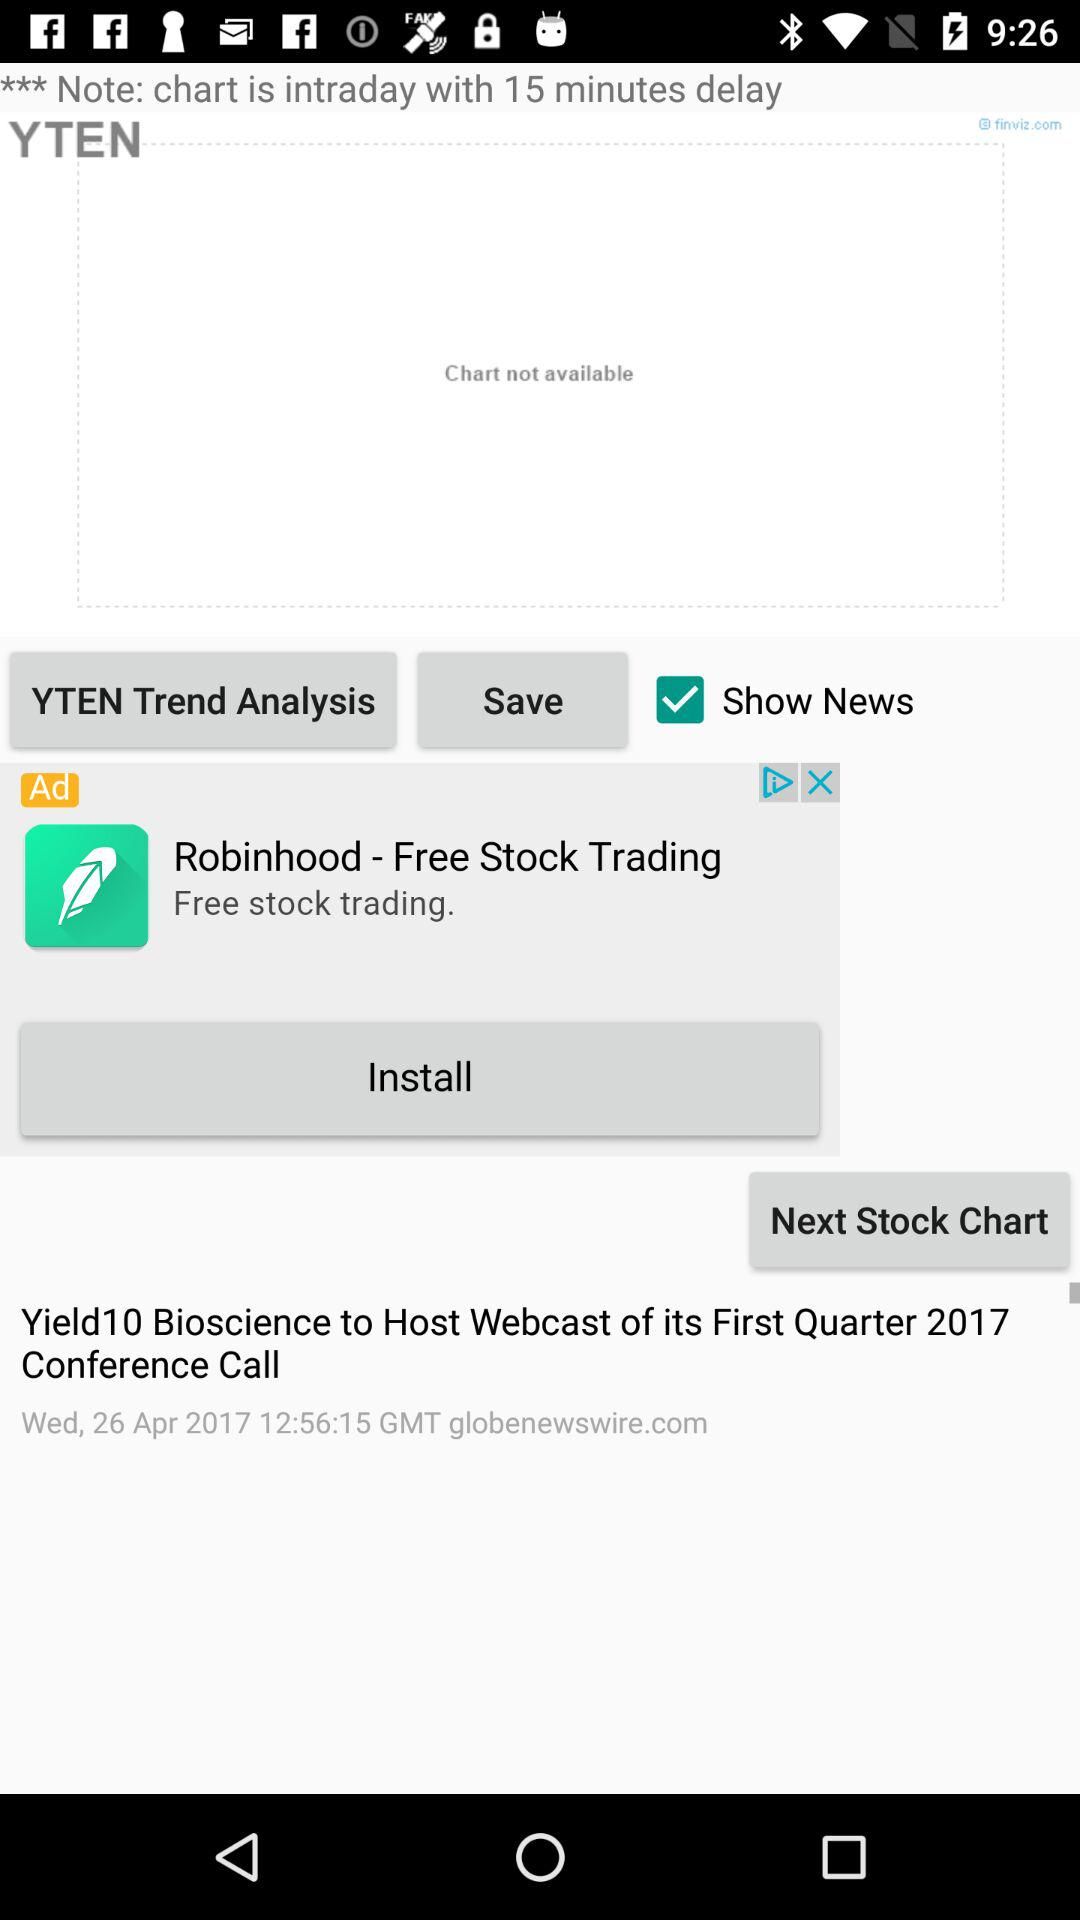What is the status of the "Show News"? The status of the "Show News" is "on". 